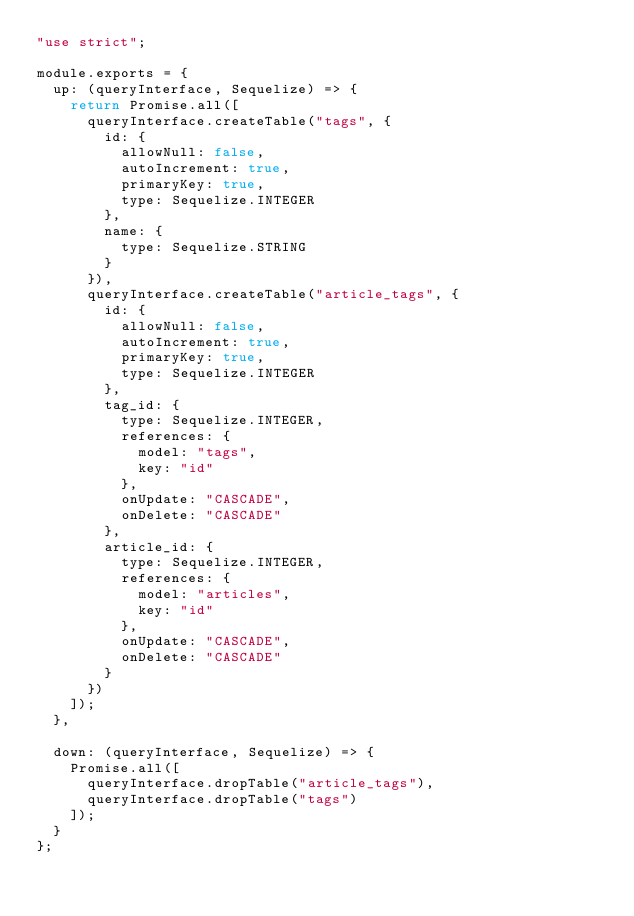<code> <loc_0><loc_0><loc_500><loc_500><_JavaScript_>"use strict";

module.exports = {
  up: (queryInterface, Sequelize) => {
    return Promise.all([
      queryInterface.createTable("tags", {
        id: {
          allowNull: false,
          autoIncrement: true,
          primaryKey: true,
          type: Sequelize.INTEGER
        },
        name: {
          type: Sequelize.STRING
        }
      }),
      queryInterface.createTable("article_tags", {
        id: {
          allowNull: false,
          autoIncrement: true,
          primaryKey: true,
          type: Sequelize.INTEGER
        },
        tag_id: {
          type: Sequelize.INTEGER,
          references: {
            model: "tags",
            key: "id"
          },
          onUpdate: "CASCADE",
          onDelete: "CASCADE"
        },
        article_id: {
          type: Sequelize.INTEGER,
          references: {
            model: "articles",
            key: "id"
          },
          onUpdate: "CASCADE",
          onDelete: "CASCADE"
        }
      })
    ]);
  },

  down: (queryInterface, Sequelize) => {
    Promise.all([
      queryInterface.dropTable("article_tags"),
      queryInterface.dropTable("tags")
    ]);
  }
};
</code> 